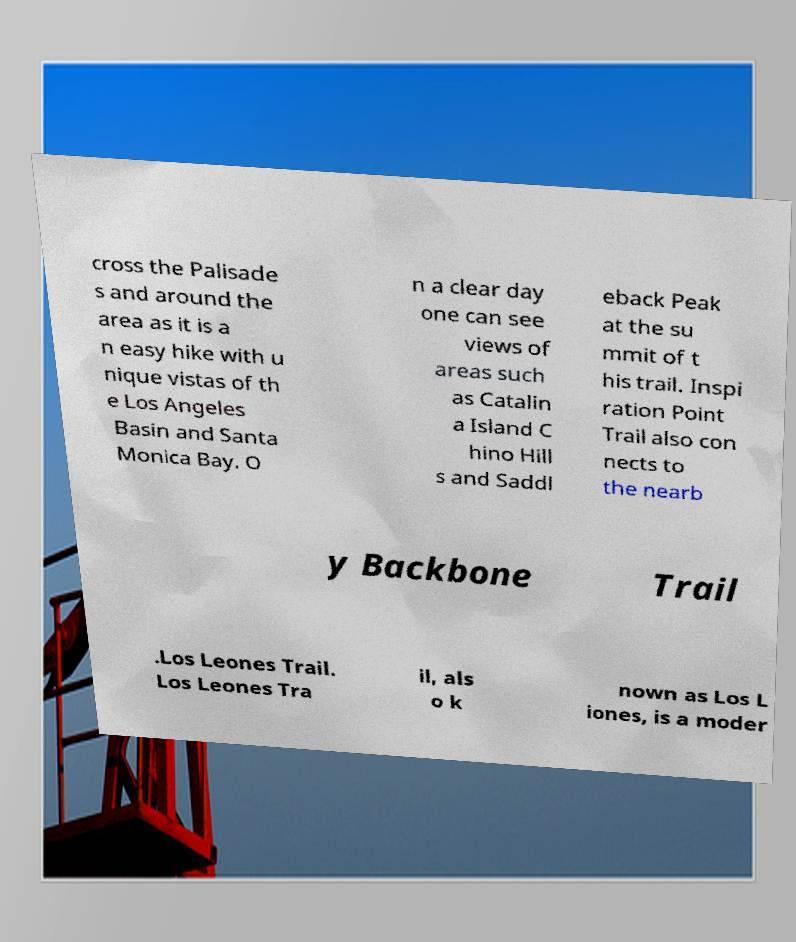Can you accurately transcribe the text from the provided image for me? cross the Palisade s and around the area as it is a n easy hike with u nique vistas of th e Los Angeles Basin and Santa Monica Bay. O n a clear day one can see views of areas such as Catalin a Island C hino Hill s and Saddl eback Peak at the su mmit of t his trail. Inspi ration Point Trail also con nects to the nearb y Backbone Trail .Los Leones Trail. Los Leones Tra il, als o k nown as Los L iones, is a moder 